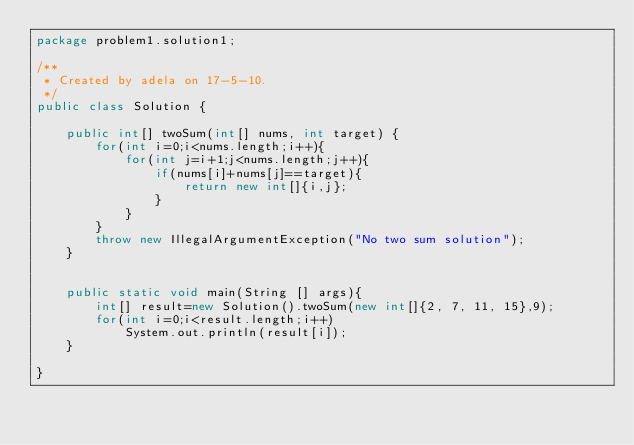Convert code to text. <code><loc_0><loc_0><loc_500><loc_500><_Java_>package problem1.solution1;

/**
 * Created by adela on 17-5-10.
 */
public class Solution {

    public int[] twoSum(int[] nums, int target) {
        for(int i=0;i<nums.length;i++){
            for(int j=i+1;j<nums.length;j++){
                if(nums[i]+nums[j]==target){
                    return new int[]{i,j};
                }
            }
        }
        throw new IllegalArgumentException("No two sum solution");
    }


    public static void main(String [] args){
        int[] result=new Solution().twoSum(new int[]{2, 7, 11, 15},9);
        for(int i=0;i<result.length;i++)
            System.out.println(result[i]);
    }

}

</code> 